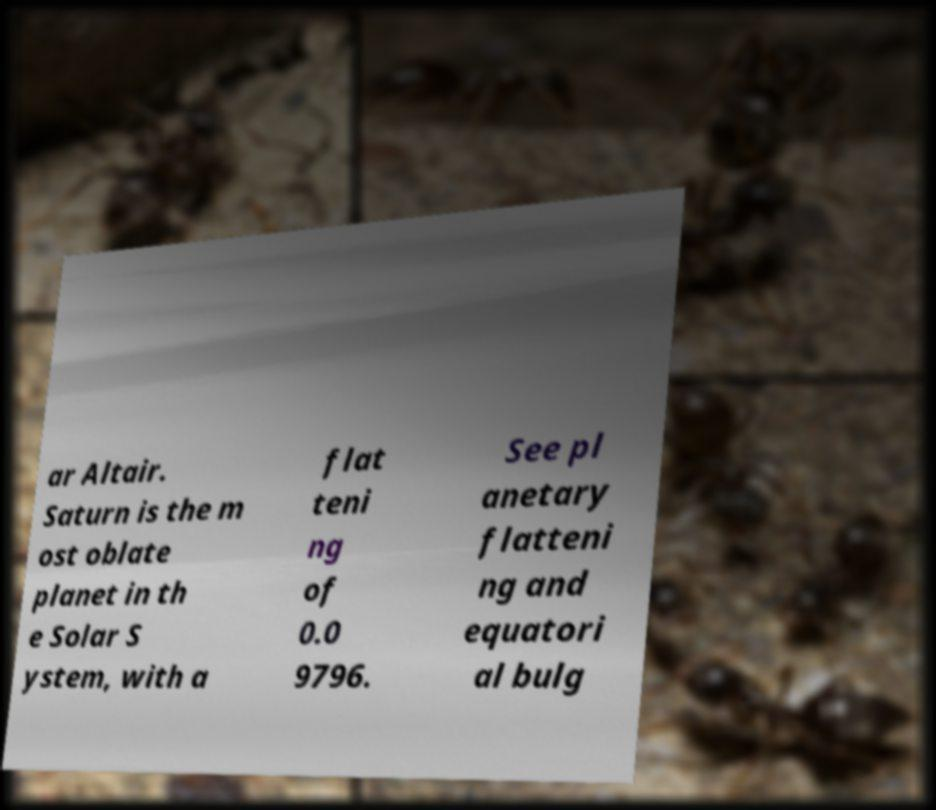There's text embedded in this image that I need extracted. Can you transcribe it verbatim? ar Altair. Saturn is the m ost oblate planet in th e Solar S ystem, with a flat teni ng of 0.0 9796. See pl anetary flatteni ng and equatori al bulg 